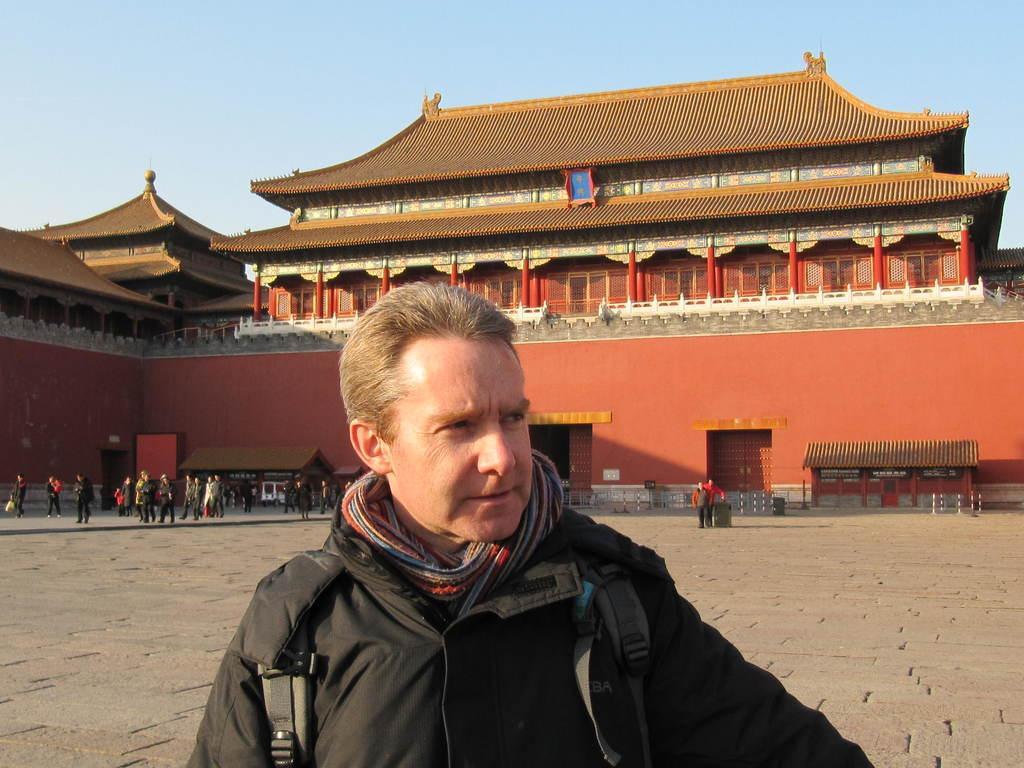Describe this image in one or two sentences. There is one man wearing a black color coat is present at the bottom of this image. We can see a group of people in the background. There is a building in the middle of this image and the sky is at the top of this image. 